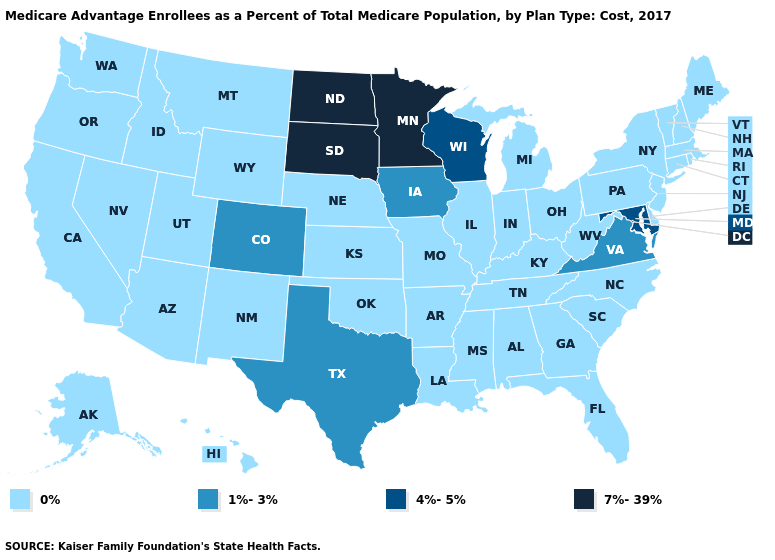Is the legend a continuous bar?
Answer briefly. No. Name the states that have a value in the range 1%-3%?
Write a very short answer. Colorado, Iowa, Texas, Virginia. What is the value of Pennsylvania?
Be succinct. 0%. Which states have the highest value in the USA?
Keep it brief. Minnesota, North Dakota, South Dakota. How many symbols are there in the legend?
Be succinct. 4. Name the states that have a value in the range 0%?
Concise answer only. Alaska, Alabama, Arkansas, Arizona, California, Connecticut, Delaware, Florida, Georgia, Hawaii, Idaho, Illinois, Indiana, Kansas, Kentucky, Louisiana, Massachusetts, Maine, Michigan, Missouri, Mississippi, Montana, North Carolina, Nebraska, New Hampshire, New Jersey, New Mexico, Nevada, New York, Ohio, Oklahoma, Oregon, Pennsylvania, Rhode Island, South Carolina, Tennessee, Utah, Vermont, Washington, West Virginia, Wyoming. Does Arkansas have the lowest value in the USA?
Answer briefly. Yes. What is the value of New Jersey?
Concise answer only. 0%. Which states have the lowest value in the West?
Keep it brief. Alaska, Arizona, California, Hawaii, Idaho, Montana, New Mexico, Nevada, Oregon, Utah, Washington, Wyoming. Which states have the lowest value in the USA?
Short answer required. Alaska, Alabama, Arkansas, Arizona, California, Connecticut, Delaware, Florida, Georgia, Hawaii, Idaho, Illinois, Indiana, Kansas, Kentucky, Louisiana, Massachusetts, Maine, Michigan, Missouri, Mississippi, Montana, North Carolina, Nebraska, New Hampshire, New Jersey, New Mexico, Nevada, New York, Ohio, Oklahoma, Oregon, Pennsylvania, Rhode Island, South Carolina, Tennessee, Utah, Vermont, Washington, West Virginia, Wyoming. Does Illinois have the highest value in the MidWest?
Answer briefly. No. Among the states that border Arizona , which have the lowest value?
Be succinct. California, New Mexico, Nevada, Utah. Does Nevada have the lowest value in the USA?
Concise answer only. Yes. 